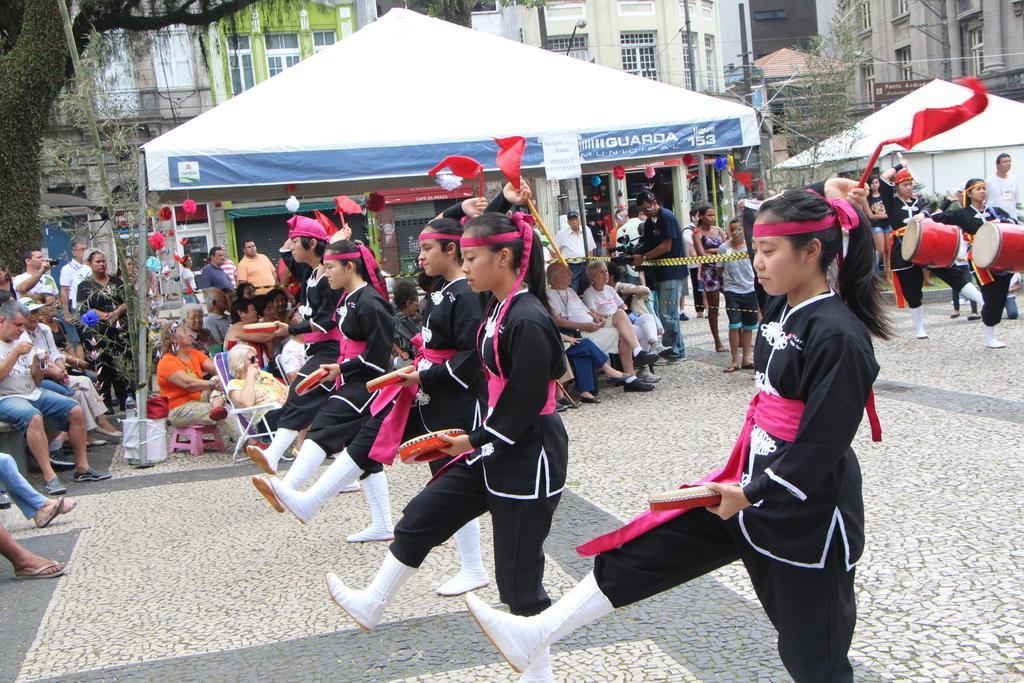In one or two sentences, can you explain what this image depicts? In this picture I can see buildings trees and few tents and I can see few people seated on the chairs and few are playing drums and few are dancing and I can see a man holding a camera in his hand. 